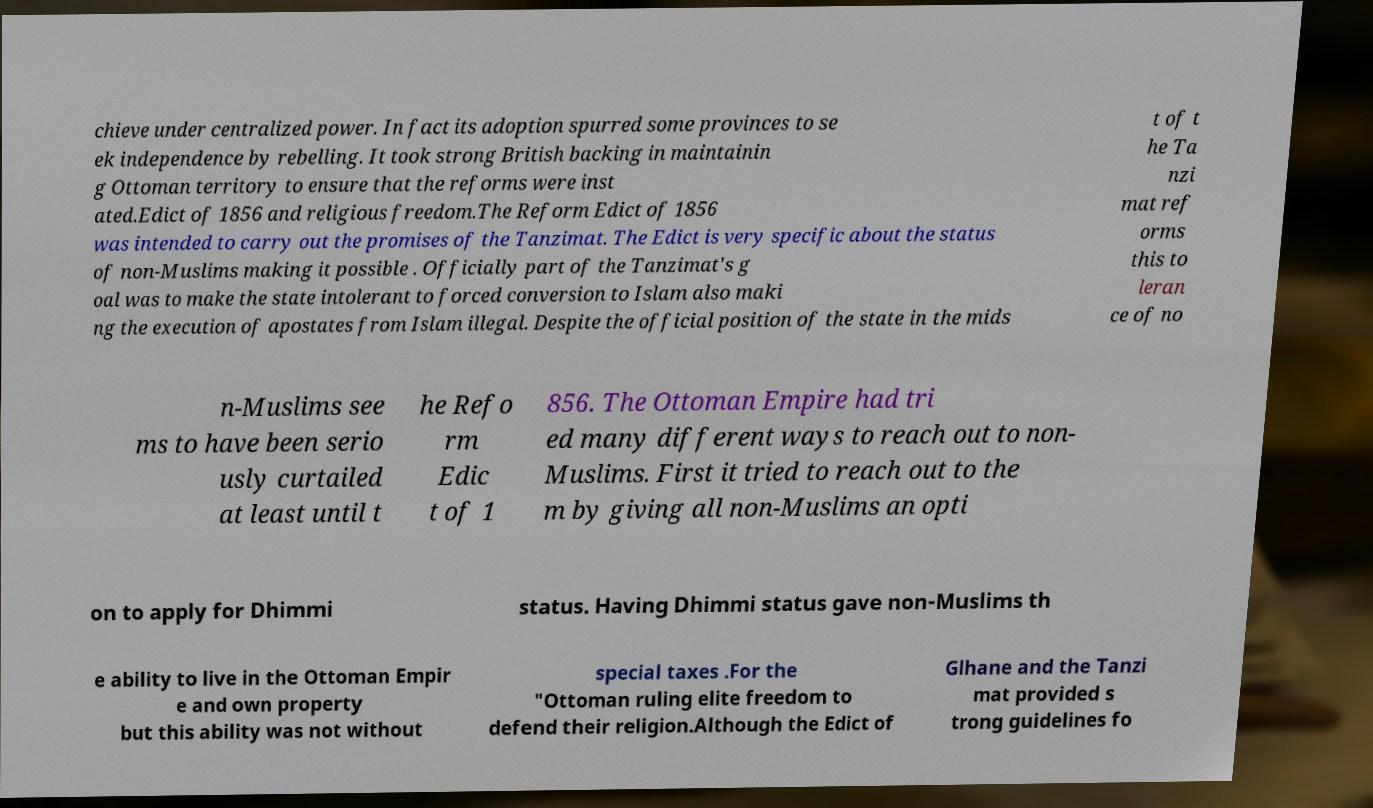Please identify and transcribe the text found in this image. chieve under centralized power. In fact its adoption spurred some provinces to se ek independence by rebelling. It took strong British backing in maintainin g Ottoman territory to ensure that the reforms were inst ated.Edict of 1856 and religious freedom.The Reform Edict of 1856 was intended to carry out the promises of the Tanzimat. The Edict is very specific about the status of non-Muslims making it possible . Officially part of the Tanzimat's g oal was to make the state intolerant to forced conversion to Islam also maki ng the execution of apostates from Islam illegal. Despite the official position of the state in the mids t of t he Ta nzi mat ref orms this to leran ce of no n-Muslims see ms to have been serio usly curtailed at least until t he Refo rm Edic t of 1 856. The Ottoman Empire had tri ed many different ways to reach out to non- Muslims. First it tried to reach out to the m by giving all non-Muslims an opti on to apply for Dhimmi status. Having Dhimmi status gave non-Muslims th e ability to live in the Ottoman Empir e and own property but this ability was not without special taxes .For the "Ottoman ruling elite freedom to defend their religion.Although the Edict of Glhane and the Tanzi mat provided s trong guidelines fo 